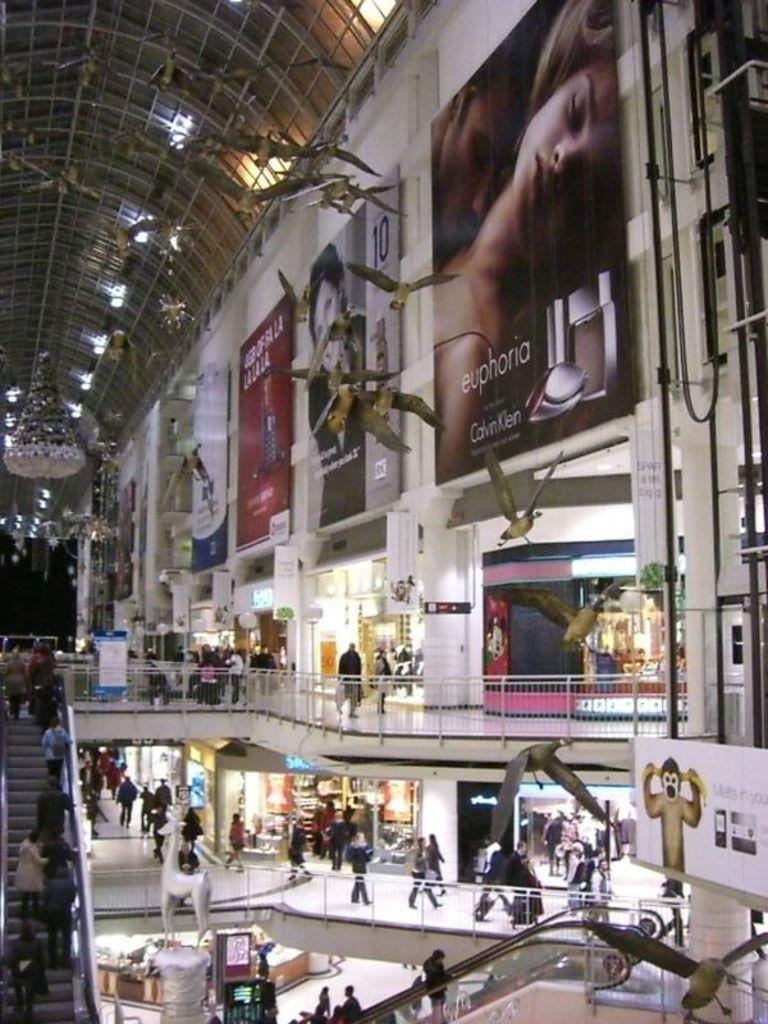In one or two sentences, can you explain what this image depicts? This picture was taken in the shopping mall. These are the hoardings. I can see groups of people walking. This looks like an escalator. I think this is the sculpture of an animal. These are the birds flying. I can see the shops with the glass doors and lights. This looks like a ceiling. On the right side of the image, I think this is an elevator. 